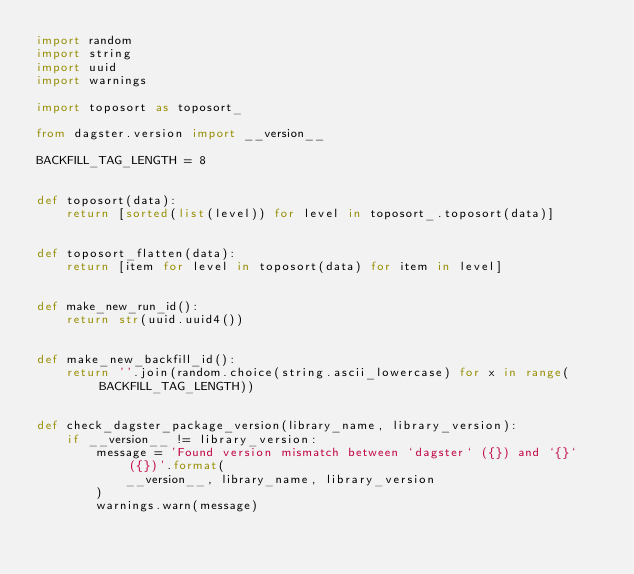Convert code to text. <code><loc_0><loc_0><loc_500><loc_500><_Python_>import random
import string
import uuid
import warnings

import toposort as toposort_

from dagster.version import __version__

BACKFILL_TAG_LENGTH = 8


def toposort(data):
    return [sorted(list(level)) for level in toposort_.toposort(data)]


def toposort_flatten(data):
    return [item for level in toposort(data) for item in level]


def make_new_run_id():
    return str(uuid.uuid4())


def make_new_backfill_id():
    return ''.join(random.choice(string.ascii_lowercase) for x in range(BACKFILL_TAG_LENGTH))


def check_dagster_package_version(library_name, library_version):
    if __version__ != library_version:
        message = 'Found version mismatch between `dagster` ({}) and `{}` ({})'.format(
            __version__, library_name, library_version
        )
        warnings.warn(message)
</code> 